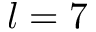<formula> <loc_0><loc_0><loc_500><loc_500>l = 7</formula> 